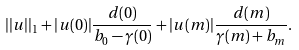Convert formula to latex. <formula><loc_0><loc_0><loc_500><loc_500>| | u | | _ { 1 } + | u ( 0 ) | \frac { d ( 0 ) } { b _ { 0 } - \gamma ( 0 ) } + | u ( m ) | \frac { d ( m ) } { \gamma ( m ) + b _ { m } } .</formula> 